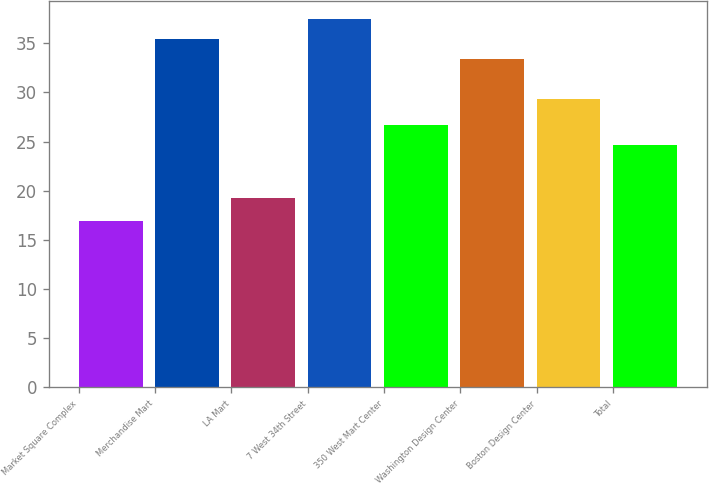Convert chart to OTSL. <chart><loc_0><loc_0><loc_500><loc_500><bar_chart><fcel>Market Square Complex<fcel>Merchandise Mart<fcel>LA Mart<fcel>7 West 34th Street<fcel>350 West Mart Center<fcel>Washington Design Center<fcel>Boston Design Center<fcel>Total<nl><fcel>16.94<fcel>35.39<fcel>19.3<fcel>37.42<fcel>26.64<fcel>33.36<fcel>29.31<fcel>24.61<nl></chart> 